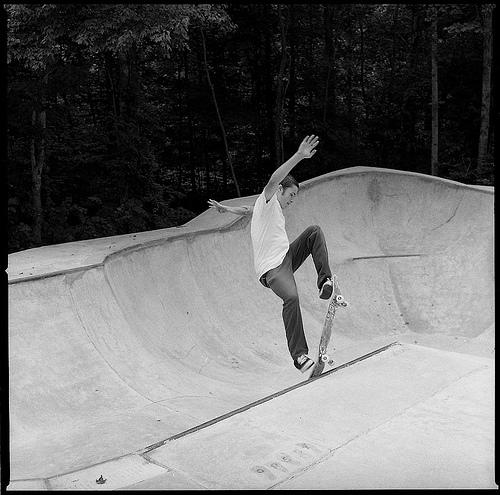What is the skateboarding in?
Write a very short answer. Bowl. Which letters are the man's shadow touching?
Be succinct. None. Why does the skateboarder have his arm upraised?
Write a very short answer. Balance. Is this a man or woman?
Keep it brief. Man. Which arm is higher in the air?
Quick response, please. Right. 